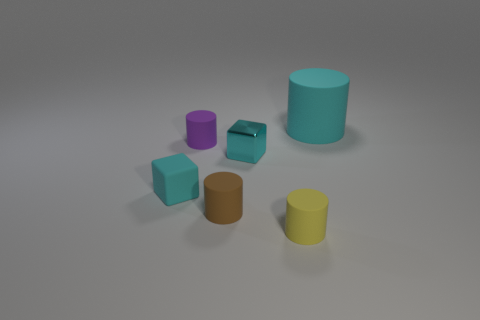Subtract all tiny purple rubber cylinders. How many cylinders are left? 3 Add 3 tiny purple rubber cylinders. How many objects exist? 9 Subtract 1 blocks. How many blocks are left? 1 Subtract all yellow cylinders. How many cylinders are left? 3 Subtract all blocks. How many objects are left? 4 Subtract all small cyan cubes. Subtract all small cyan metallic blocks. How many objects are left? 3 Add 6 tiny shiny objects. How many tiny shiny objects are left? 7 Add 4 gray matte spheres. How many gray matte spheres exist? 4 Subtract 0 red cubes. How many objects are left? 6 Subtract all green cylinders. Subtract all blue balls. How many cylinders are left? 4 